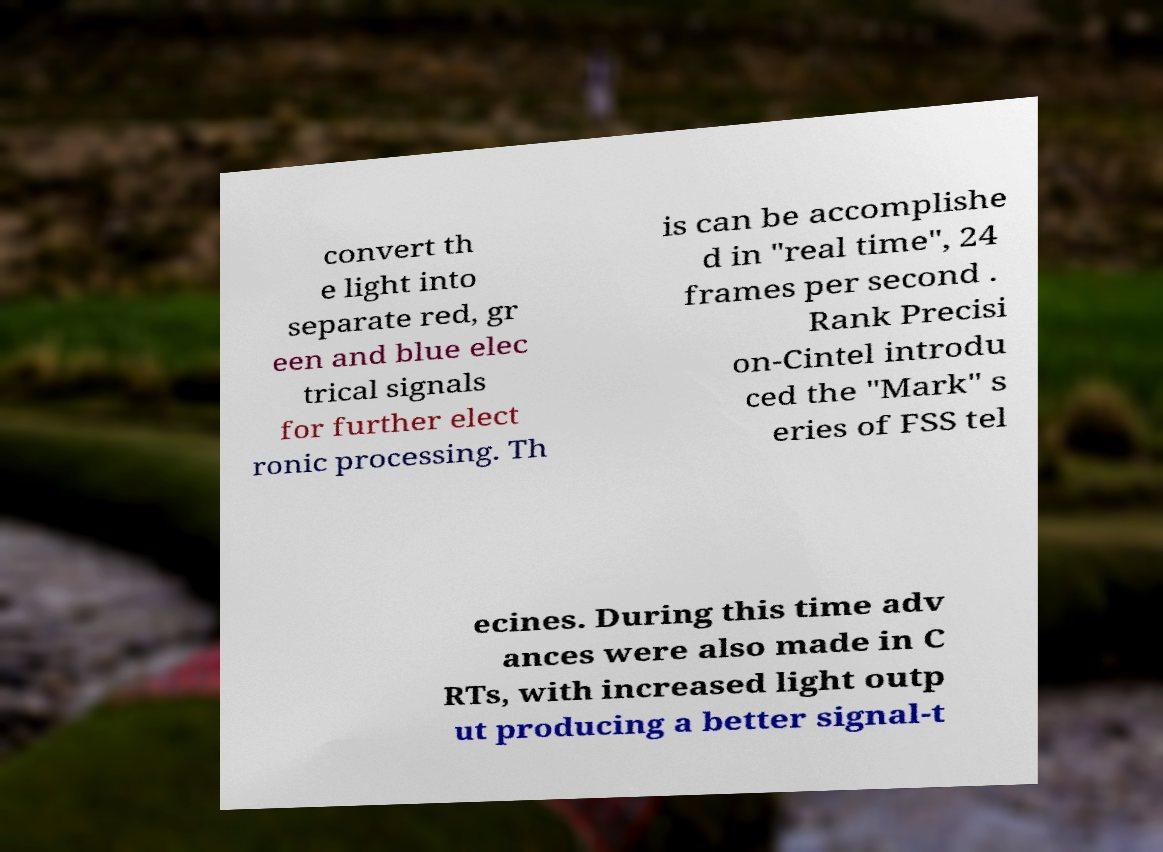Could you assist in decoding the text presented in this image and type it out clearly? convert th e light into separate red, gr een and blue elec trical signals for further elect ronic processing. Th is can be accomplishe d in "real time", 24 frames per second . Rank Precisi on-Cintel introdu ced the "Mark" s eries of FSS tel ecines. During this time adv ances were also made in C RTs, with increased light outp ut producing a better signal-t 